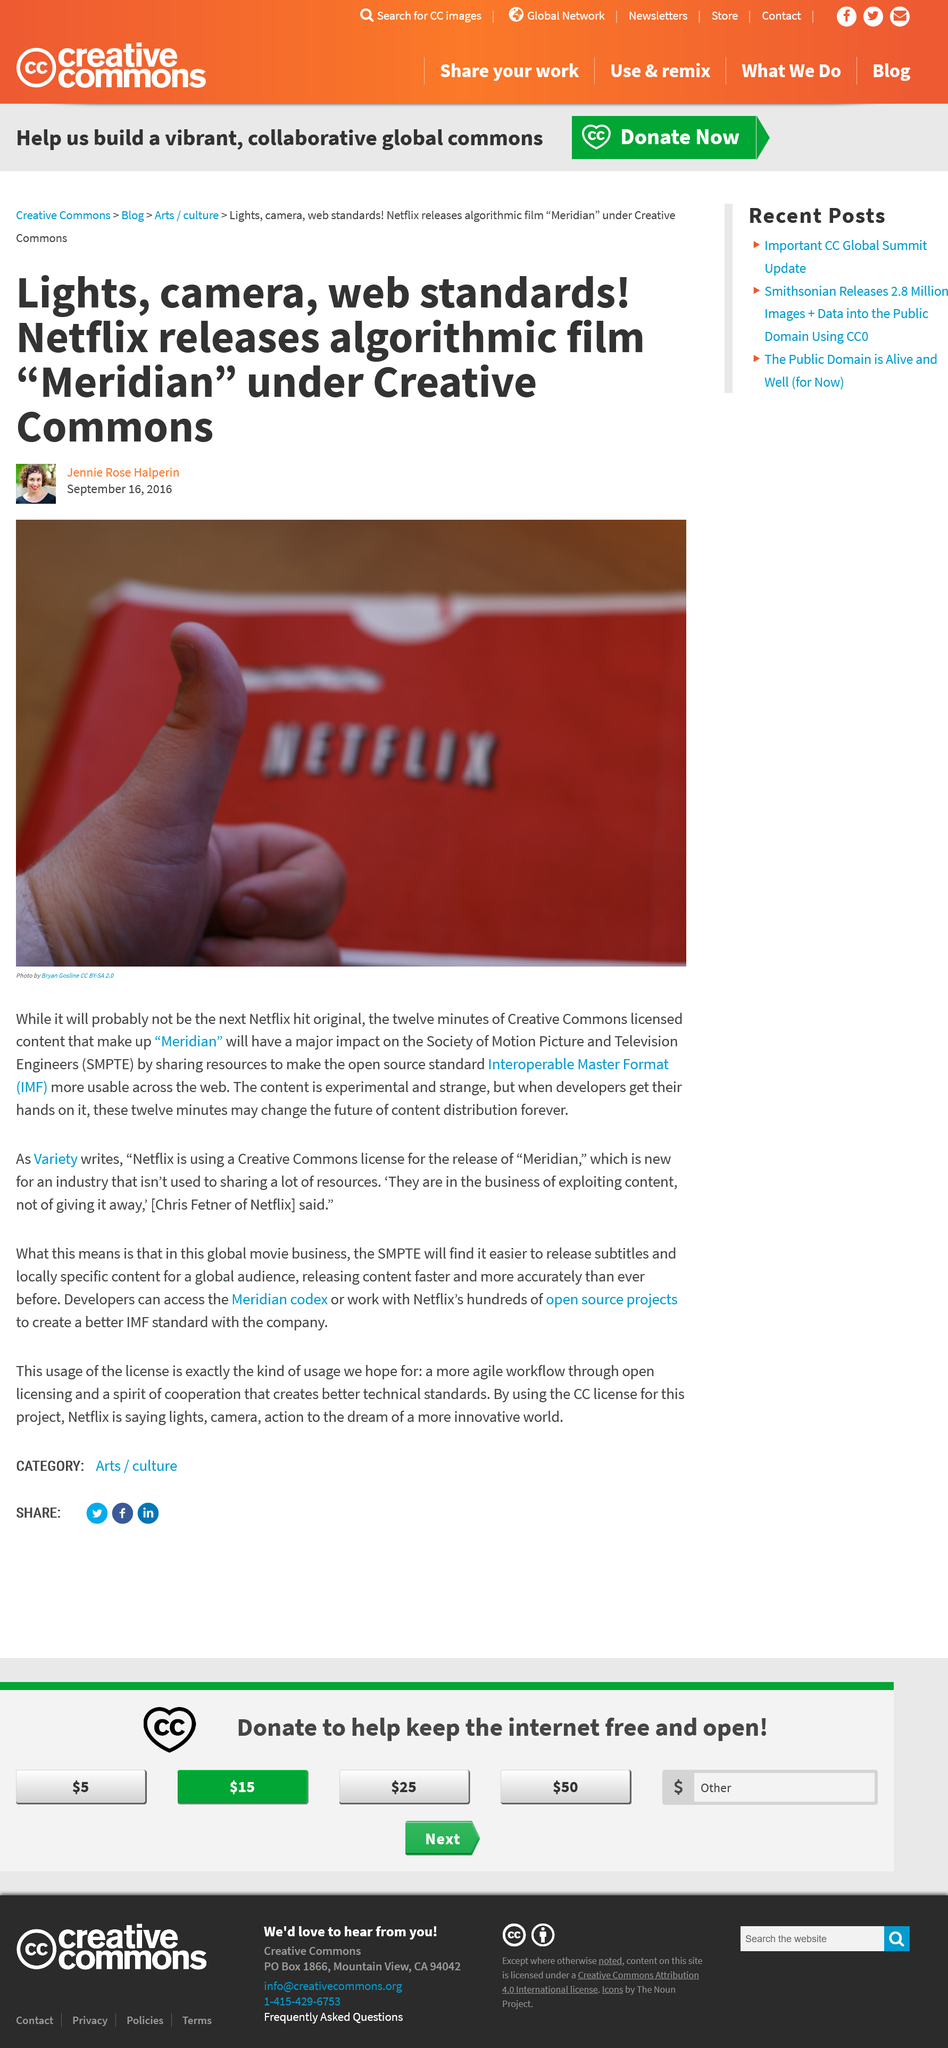Mention a couple of crucial points in this snapshot. The initialism SMPTE stands for the Society of Motion Picture and Television Engineers. The company name that can be seen in Bryan Gosline's photograph is Netflix. According to available information, the Netflix film "Meridian" is approximately twelve minutes in length. 